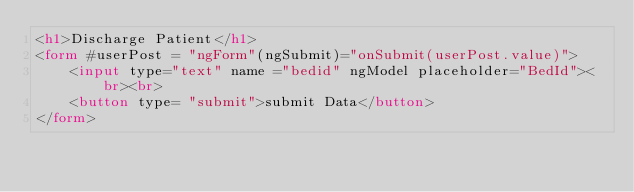<code> <loc_0><loc_0><loc_500><loc_500><_HTML_><h1>Discharge Patient</h1>
<form #userPost = "ngForm"(ngSubmit)="onSubmit(userPost.value)">
    <input type="text" name ="bedid" ngModel placeholder="BedId"><br><br>
    <button type= "submit">submit Data</button>
</form></code> 